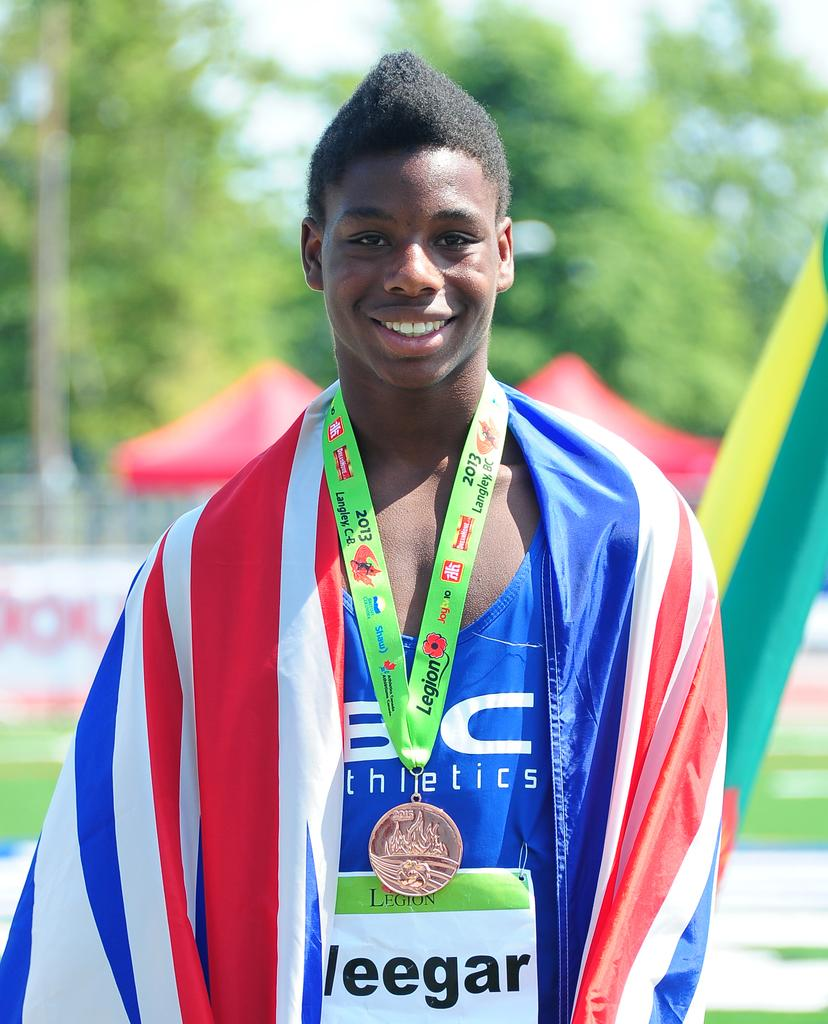What is the main subject of the image? There is a person standing in the image. What is the person's facial expression? The person is smiling. What is the person wearing in the image? The person is wearing a medal. How would you describe the background of the image? The background of the image is blurry. What type of brass instrument is the person playing in the image? There is no brass instrument present in the image; the person is wearing a medal and not playing any instrument. 